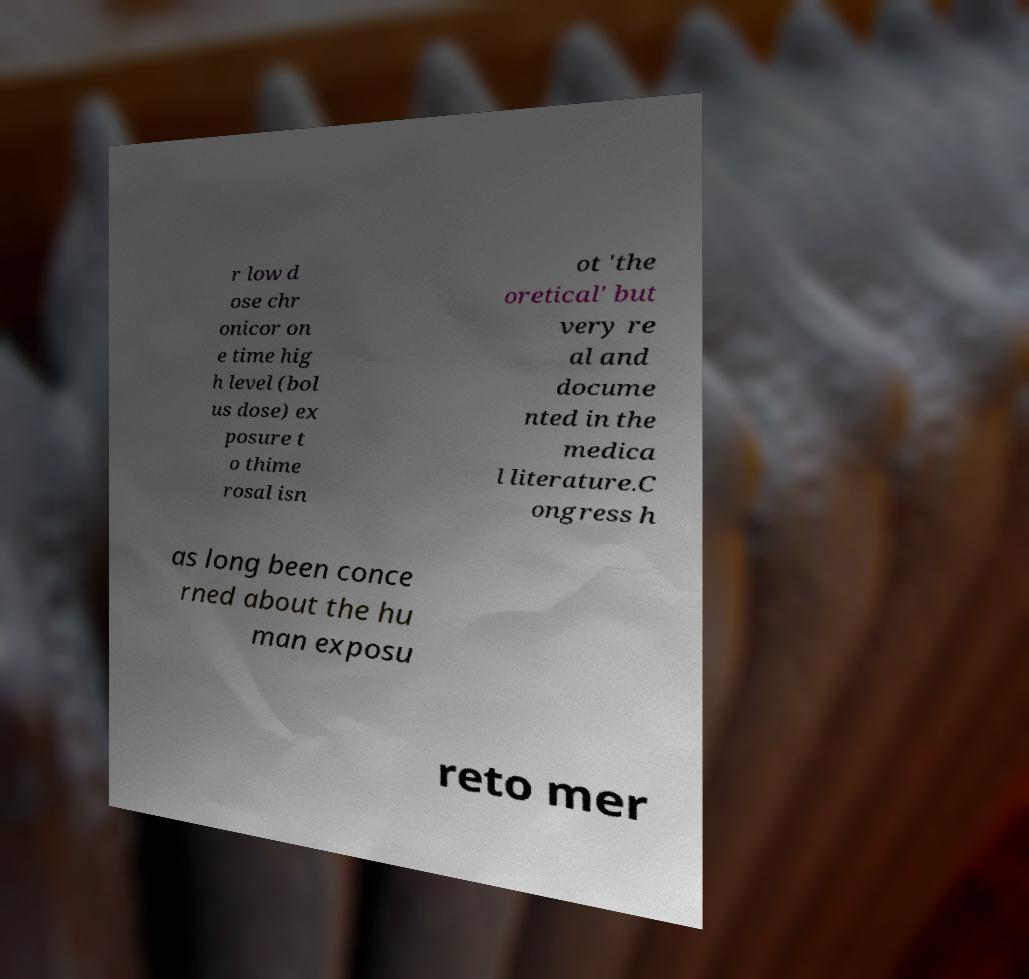For documentation purposes, I need the text within this image transcribed. Could you provide that? r low d ose chr onicor on e time hig h level (bol us dose) ex posure t o thime rosal isn ot 'the oretical' but very re al and docume nted in the medica l literature.C ongress h as long been conce rned about the hu man exposu reto mer 